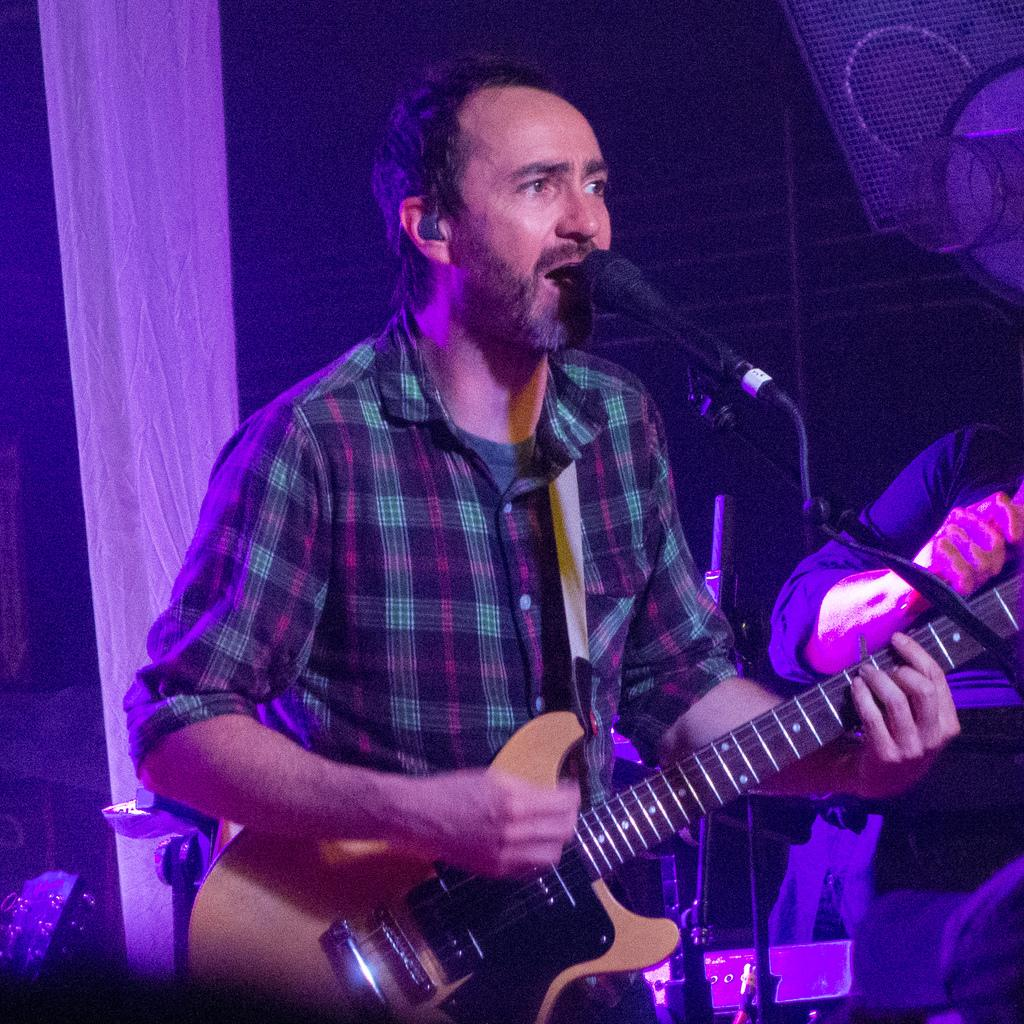What is the main subject of the image? The main subject of the image is a man. What is the man doing in the image? The man is standing, playing a guitar, singing, and using a microphone. What type of property does the man own in the image? There is no information about the man owning any property in the image. How many apples can be seen in the image? There are no apples present in the image. 